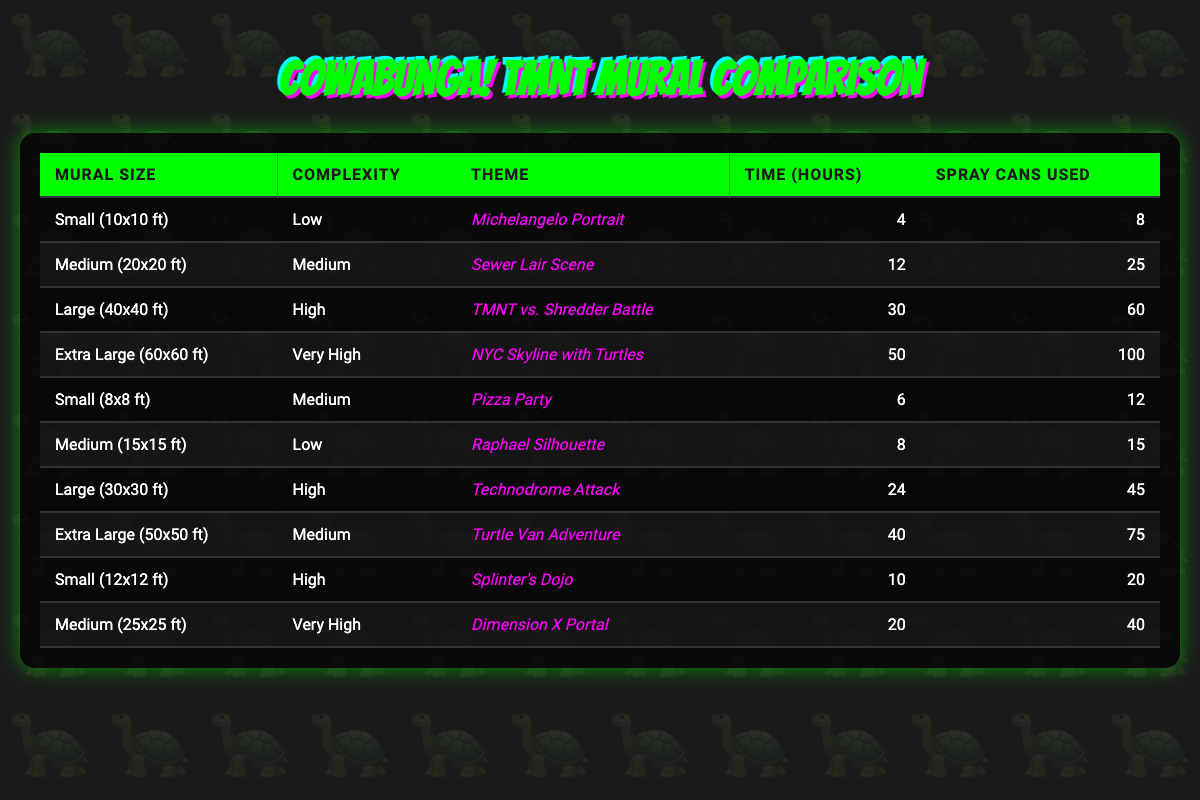What is the time required to complete the Extra Large mural? The time listed for the Extra Large mural (60x60 ft) is in the fourth column of the table. Looking at the specific row, it states that it takes 50 hours to complete the mural.
Answer: 50 hours Which mural requires the most spray cans? To find the mural that requires the most spray cans, we need to check the fifth column for all murals and find the maximum value. The Extra Large mural (60x60 ft) requires 100 spray cans, which is the highest in the table.
Answer: 100 spray cans What is the total time required for all Medium murals? The Medium murals are listed in the second column. The times for Medium murals are 12 hours (20x20 ft), 6 hours (8x8 ft), and 40 hours (50x50 ft). Adding these times gives us 12 + 6 + 40 = 58 hours total for all Medium murals.
Answer: 58 hours Is there a mural with Low complexity that takes more time than 10 hours? We need to look at the second column for Low complexity murals. The Low complexity murals are: 4 hours (10x10 ft) and 8 hours (15x15 ft). None of them exceed 10 hours. Therefore, the answer is false.
Answer: No What is the average time required for Small murals? The Small murals from the table include: 4 hours (10x10 ft), 6 hours (8x8 ft), and 10 hours (12x12 ft). First, we sum these hours: 4 + 6 + 10 = 20 hours. Then, we divide by the number of Small murals, which is 3, resulting in an average of 20 / 3 = approximately 6.67 hours.
Answer: 6.67 hours Which mural has a Very High complexity and what is its time? According to the table, the Very High complexity mural is the Medium mural (25x25 ft) which takes 20 hours. This information is found in the second and fourth columns of that specific row.
Answer: 20 hours How much more time does the Extra Large mural take compared to the Small (10x10 ft) mural? The Extra Large mural takes 50 hours, and the Small (10x10 ft) mural takes 4 hours. So, we subtract the latter from the former: 50 - 4 = 46 hours more for the Extra Large mural.
Answer: 46 hours Are there any murals that take less than 10 hours and have High complexity? Looking at the High complexity row, the only murals are Splinter's Dojo at 10 hours and Technodrome Attack at 24 hours. Since neither is under 10 hours, the answer is false.
Answer: No 